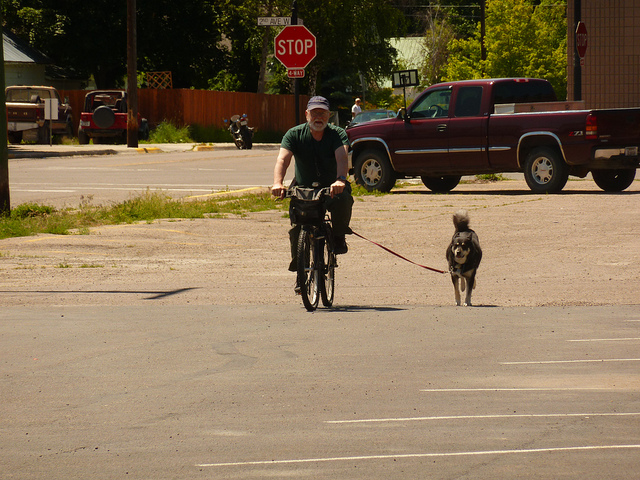<image>What kind of dogs is the man walking? I am not sure what kind of dogs the man is walking. It could be a husky, black lab, german shepherd, or a mutt. What kind of dogs is the man walking? I don't know what kind of dogs the man is walking. It can be a mutt, husky, black lab, german sheppard, lab, or german shepherd. 